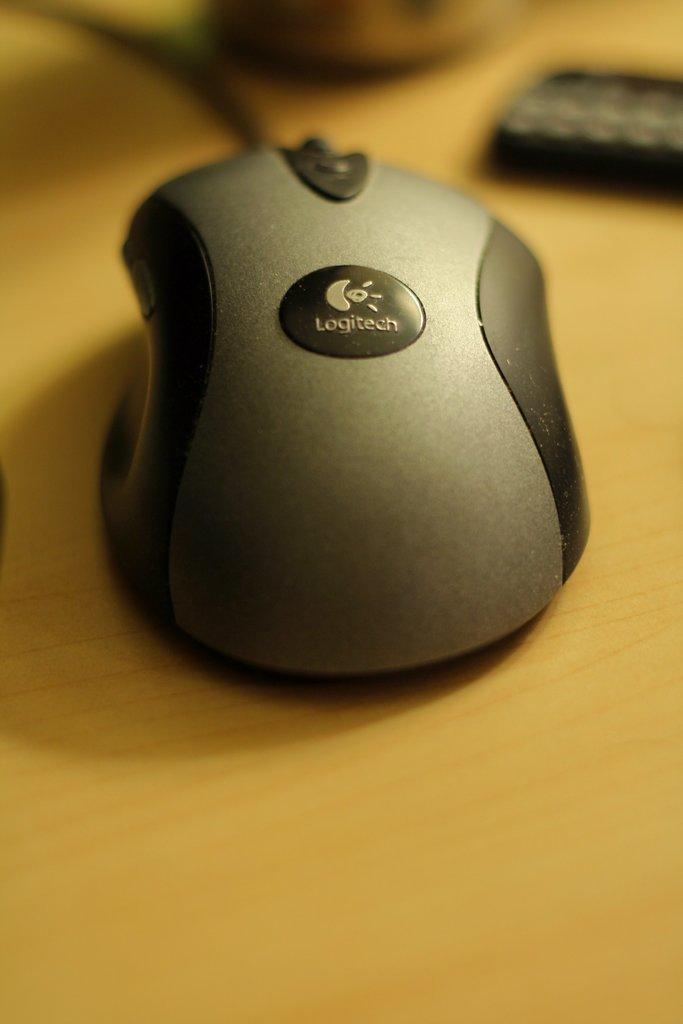In one or two sentences, can you explain what this image depicts? In this picture we can see a mouse on the wooden surface and in the background we can see some objects and it is blurry. 